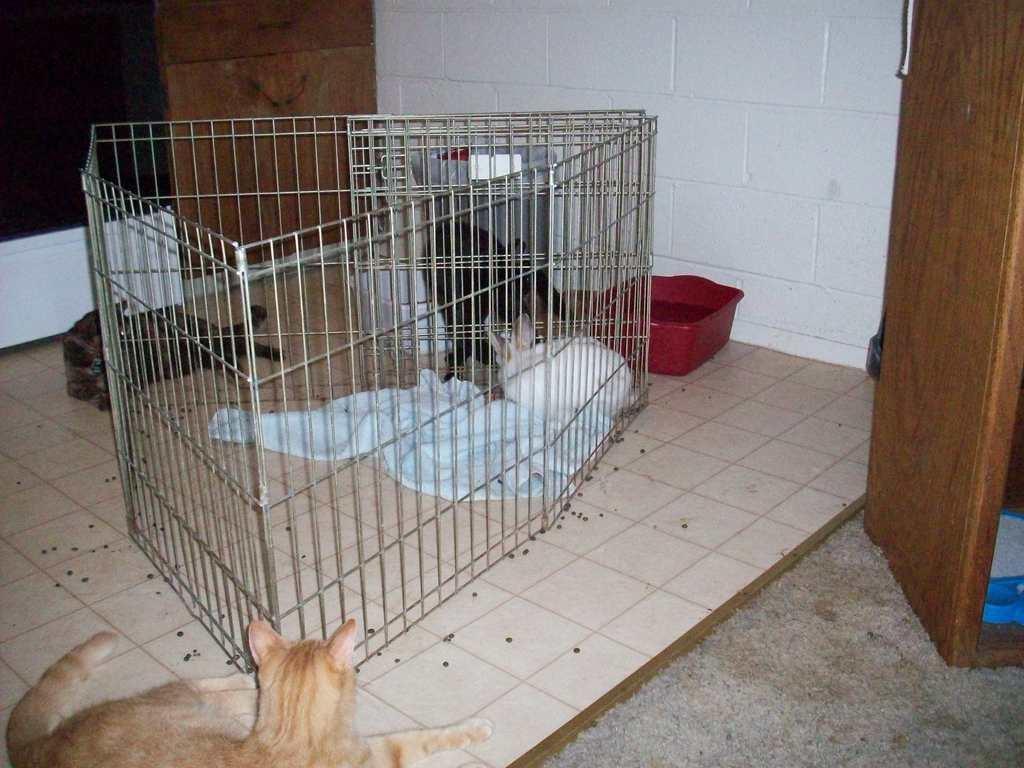Could you give a brief overview of what you see in this image? In this image we can see a cloth and a rabbit in a cage. Around the cage we can see three animals. Behind the cage we can see a wall and few plastic boxes. On the right side, we can see a wooden object. 